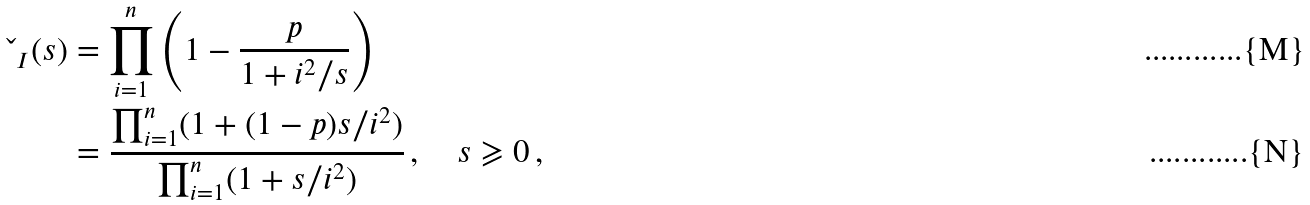<formula> <loc_0><loc_0><loc_500><loc_500>\L _ { I } ( s ) & = \prod _ { i = 1 } ^ { n } \left ( 1 - \frac { p } { 1 + i ^ { 2 } / s } \right ) \\ & = \frac { \prod _ { i = 1 } ^ { n } ( 1 + ( 1 - p ) s / i ^ { 2 } ) } { \prod _ { i = 1 } ^ { n } ( 1 + s / i ^ { 2 } ) } \, , \quad s \geqslant 0 \, ,</formula> 